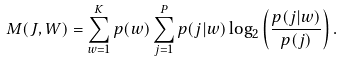Convert formula to latex. <formula><loc_0><loc_0><loc_500><loc_500>M ( J , W ) = \sum _ { w = 1 } ^ { K } p ( w ) \sum _ { j = 1 } ^ { P } p ( j | w ) \log _ { 2 } \left ( \frac { p ( j | w ) } { p ( j ) } \right ) .</formula> 